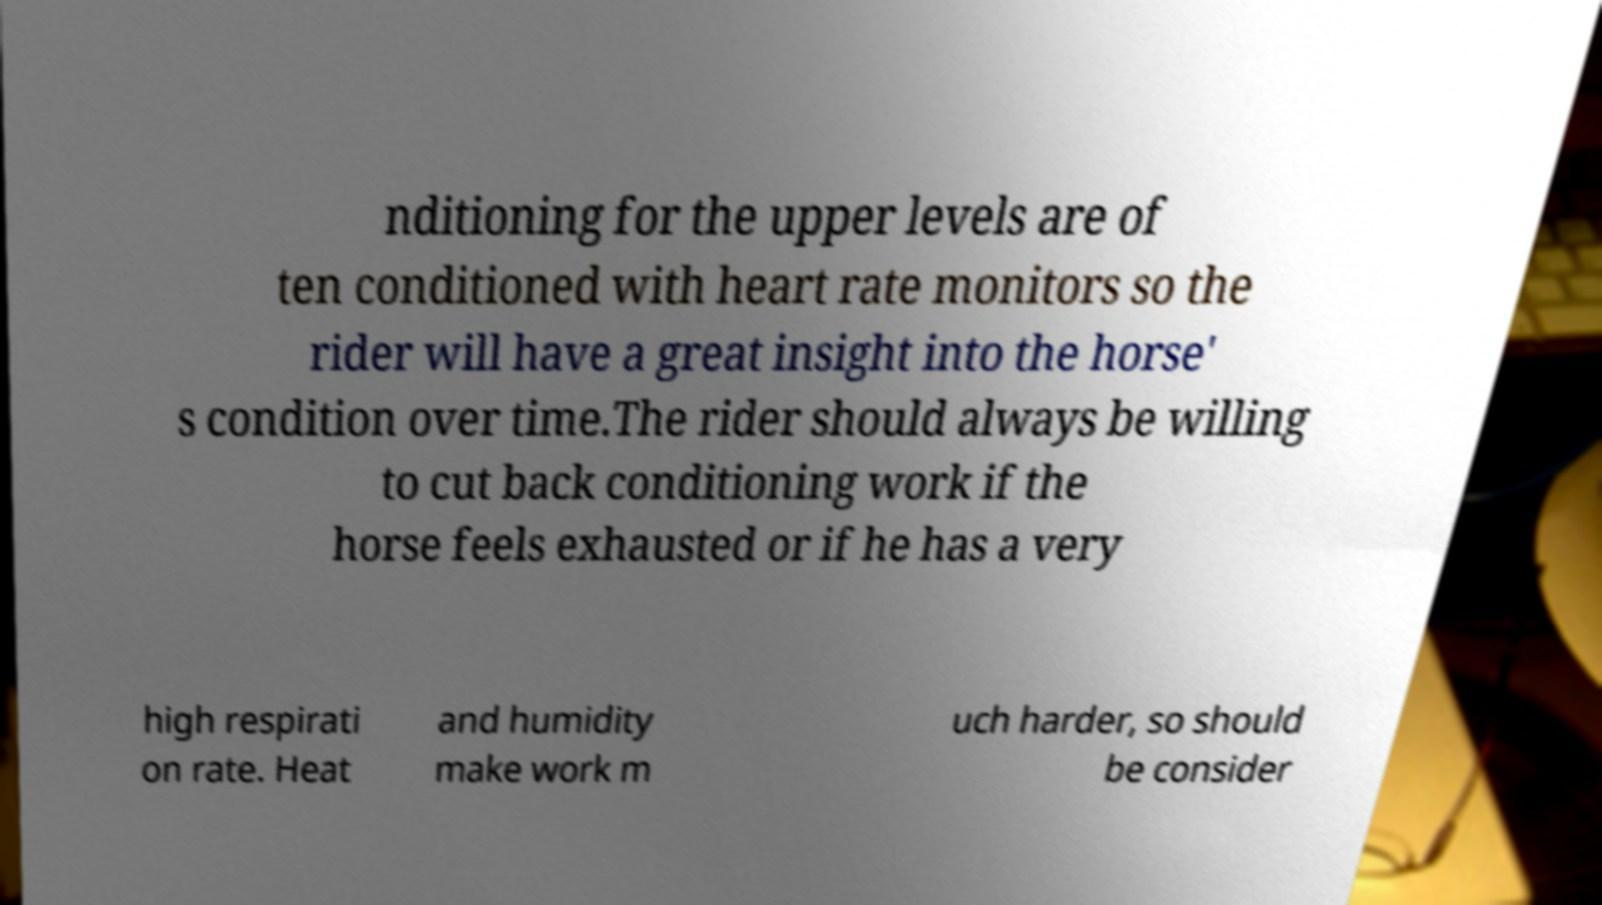I need the written content from this picture converted into text. Can you do that? nditioning for the upper levels are of ten conditioned with heart rate monitors so the rider will have a great insight into the horse' s condition over time.The rider should always be willing to cut back conditioning work if the horse feels exhausted or if he has a very high respirati on rate. Heat and humidity make work m uch harder, so should be consider 